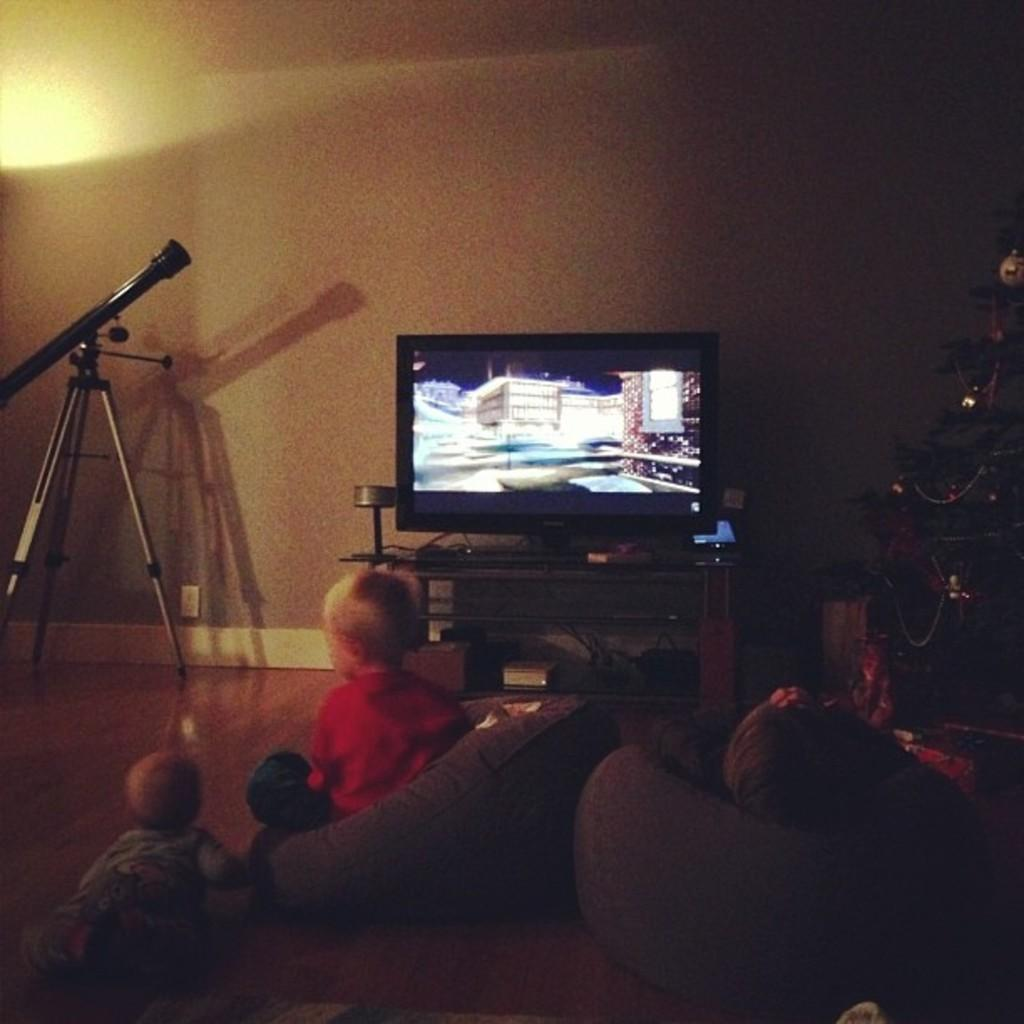How many people are sitting on the ground in the image? There are three persons sitting on the ground in the image. What can be seen in the background of the image? There is a Christmas tree, a television placed on a table, and a telescope in the background. What type of rice is being cooked in the image? There is no rice present in the image. How many snails can be seen crawling on the persons sitting on the ground? There are no snails visible in the image; only the three persons sitting on the ground are present. 